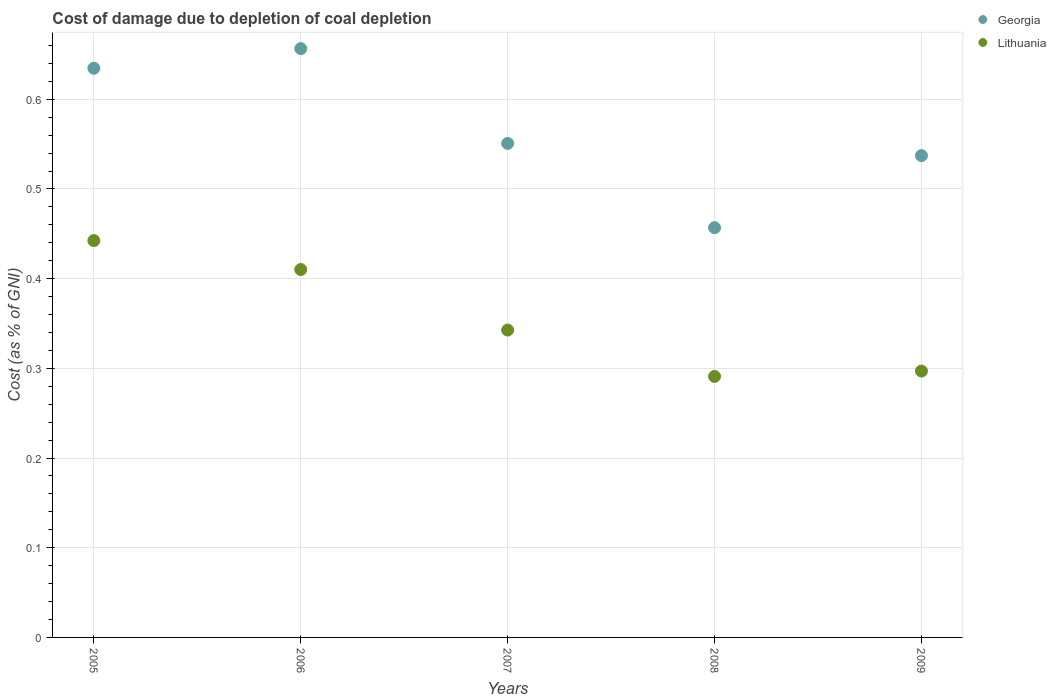What is the cost of damage caused due to coal depletion in Lithuania in 2008?
Offer a very short reply. 0.29. Across all years, what is the maximum cost of damage caused due to coal depletion in Lithuania?
Your answer should be compact. 0.44. Across all years, what is the minimum cost of damage caused due to coal depletion in Lithuania?
Your answer should be compact. 0.29. In which year was the cost of damage caused due to coal depletion in Lithuania minimum?
Provide a short and direct response. 2008. What is the total cost of damage caused due to coal depletion in Georgia in the graph?
Provide a succinct answer. 2.84. What is the difference between the cost of damage caused due to coal depletion in Lithuania in 2007 and that in 2008?
Ensure brevity in your answer.  0.05. What is the difference between the cost of damage caused due to coal depletion in Georgia in 2005 and the cost of damage caused due to coal depletion in Lithuania in 2008?
Keep it short and to the point. 0.34. What is the average cost of damage caused due to coal depletion in Georgia per year?
Keep it short and to the point. 0.57. In the year 2006, what is the difference between the cost of damage caused due to coal depletion in Lithuania and cost of damage caused due to coal depletion in Georgia?
Ensure brevity in your answer.  -0.25. In how many years, is the cost of damage caused due to coal depletion in Lithuania greater than 0.56 %?
Your response must be concise. 0. What is the ratio of the cost of damage caused due to coal depletion in Lithuania in 2008 to that in 2009?
Your answer should be compact. 0.98. Is the difference between the cost of damage caused due to coal depletion in Lithuania in 2006 and 2007 greater than the difference between the cost of damage caused due to coal depletion in Georgia in 2006 and 2007?
Provide a succinct answer. No. What is the difference between the highest and the second highest cost of damage caused due to coal depletion in Georgia?
Ensure brevity in your answer.  0.02. What is the difference between the highest and the lowest cost of damage caused due to coal depletion in Georgia?
Your answer should be compact. 0.2. In how many years, is the cost of damage caused due to coal depletion in Georgia greater than the average cost of damage caused due to coal depletion in Georgia taken over all years?
Provide a short and direct response. 2. Is the sum of the cost of damage caused due to coal depletion in Georgia in 2008 and 2009 greater than the maximum cost of damage caused due to coal depletion in Lithuania across all years?
Your response must be concise. Yes. Is the cost of damage caused due to coal depletion in Georgia strictly greater than the cost of damage caused due to coal depletion in Lithuania over the years?
Offer a very short reply. Yes. Is the cost of damage caused due to coal depletion in Lithuania strictly less than the cost of damage caused due to coal depletion in Georgia over the years?
Offer a terse response. Yes. How many dotlines are there?
Your response must be concise. 2. Are the values on the major ticks of Y-axis written in scientific E-notation?
Provide a short and direct response. No. How many legend labels are there?
Offer a very short reply. 2. What is the title of the graph?
Your response must be concise. Cost of damage due to depletion of coal depletion. What is the label or title of the X-axis?
Ensure brevity in your answer.  Years. What is the label or title of the Y-axis?
Offer a terse response. Cost (as % of GNI). What is the Cost (as % of GNI) of Georgia in 2005?
Keep it short and to the point. 0.63. What is the Cost (as % of GNI) in Lithuania in 2005?
Provide a short and direct response. 0.44. What is the Cost (as % of GNI) in Georgia in 2006?
Provide a short and direct response. 0.66. What is the Cost (as % of GNI) of Lithuania in 2006?
Your answer should be very brief. 0.41. What is the Cost (as % of GNI) in Georgia in 2007?
Your answer should be compact. 0.55. What is the Cost (as % of GNI) of Lithuania in 2007?
Provide a succinct answer. 0.34. What is the Cost (as % of GNI) of Georgia in 2008?
Give a very brief answer. 0.46. What is the Cost (as % of GNI) of Lithuania in 2008?
Your response must be concise. 0.29. What is the Cost (as % of GNI) of Georgia in 2009?
Make the answer very short. 0.54. What is the Cost (as % of GNI) in Lithuania in 2009?
Your answer should be compact. 0.3. Across all years, what is the maximum Cost (as % of GNI) in Georgia?
Ensure brevity in your answer.  0.66. Across all years, what is the maximum Cost (as % of GNI) of Lithuania?
Your answer should be compact. 0.44. Across all years, what is the minimum Cost (as % of GNI) in Georgia?
Your answer should be very brief. 0.46. Across all years, what is the minimum Cost (as % of GNI) in Lithuania?
Make the answer very short. 0.29. What is the total Cost (as % of GNI) in Georgia in the graph?
Provide a short and direct response. 2.84. What is the total Cost (as % of GNI) in Lithuania in the graph?
Offer a very short reply. 1.78. What is the difference between the Cost (as % of GNI) of Georgia in 2005 and that in 2006?
Make the answer very short. -0.02. What is the difference between the Cost (as % of GNI) in Lithuania in 2005 and that in 2006?
Provide a succinct answer. 0.03. What is the difference between the Cost (as % of GNI) in Georgia in 2005 and that in 2007?
Ensure brevity in your answer.  0.08. What is the difference between the Cost (as % of GNI) of Lithuania in 2005 and that in 2007?
Provide a short and direct response. 0.1. What is the difference between the Cost (as % of GNI) in Georgia in 2005 and that in 2008?
Offer a terse response. 0.18. What is the difference between the Cost (as % of GNI) of Lithuania in 2005 and that in 2008?
Provide a short and direct response. 0.15. What is the difference between the Cost (as % of GNI) in Georgia in 2005 and that in 2009?
Your response must be concise. 0.1. What is the difference between the Cost (as % of GNI) in Lithuania in 2005 and that in 2009?
Make the answer very short. 0.15. What is the difference between the Cost (as % of GNI) in Georgia in 2006 and that in 2007?
Ensure brevity in your answer.  0.11. What is the difference between the Cost (as % of GNI) of Lithuania in 2006 and that in 2007?
Give a very brief answer. 0.07. What is the difference between the Cost (as % of GNI) in Georgia in 2006 and that in 2008?
Provide a short and direct response. 0.2. What is the difference between the Cost (as % of GNI) in Lithuania in 2006 and that in 2008?
Provide a short and direct response. 0.12. What is the difference between the Cost (as % of GNI) in Georgia in 2006 and that in 2009?
Ensure brevity in your answer.  0.12. What is the difference between the Cost (as % of GNI) in Lithuania in 2006 and that in 2009?
Your answer should be very brief. 0.11. What is the difference between the Cost (as % of GNI) of Georgia in 2007 and that in 2008?
Keep it short and to the point. 0.09. What is the difference between the Cost (as % of GNI) of Lithuania in 2007 and that in 2008?
Offer a very short reply. 0.05. What is the difference between the Cost (as % of GNI) of Georgia in 2007 and that in 2009?
Offer a very short reply. 0.01. What is the difference between the Cost (as % of GNI) in Lithuania in 2007 and that in 2009?
Offer a terse response. 0.05. What is the difference between the Cost (as % of GNI) in Georgia in 2008 and that in 2009?
Keep it short and to the point. -0.08. What is the difference between the Cost (as % of GNI) in Lithuania in 2008 and that in 2009?
Make the answer very short. -0.01. What is the difference between the Cost (as % of GNI) of Georgia in 2005 and the Cost (as % of GNI) of Lithuania in 2006?
Provide a short and direct response. 0.22. What is the difference between the Cost (as % of GNI) of Georgia in 2005 and the Cost (as % of GNI) of Lithuania in 2007?
Keep it short and to the point. 0.29. What is the difference between the Cost (as % of GNI) of Georgia in 2005 and the Cost (as % of GNI) of Lithuania in 2008?
Keep it short and to the point. 0.34. What is the difference between the Cost (as % of GNI) of Georgia in 2005 and the Cost (as % of GNI) of Lithuania in 2009?
Ensure brevity in your answer.  0.34. What is the difference between the Cost (as % of GNI) in Georgia in 2006 and the Cost (as % of GNI) in Lithuania in 2007?
Offer a terse response. 0.31. What is the difference between the Cost (as % of GNI) in Georgia in 2006 and the Cost (as % of GNI) in Lithuania in 2008?
Your answer should be very brief. 0.37. What is the difference between the Cost (as % of GNI) of Georgia in 2006 and the Cost (as % of GNI) of Lithuania in 2009?
Provide a short and direct response. 0.36. What is the difference between the Cost (as % of GNI) of Georgia in 2007 and the Cost (as % of GNI) of Lithuania in 2008?
Your response must be concise. 0.26. What is the difference between the Cost (as % of GNI) of Georgia in 2007 and the Cost (as % of GNI) of Lithuania in 2009?
Offer a very short reply. 0.25. What is the difference between the Cost (as % of GNI) in Georgia in 2008 and the Cost (as % of GNI) in Lithuania in 2009?
Ensure brevity in your answer.  0.16. What is the average Cost (as % of GNI) in Georgia per year?
Offer a terse response. 0.57. What is the average Cost (as % of GNI) in Lithuania per year?
Keep it short and to the point. 0.36. In the year 2005, what is the difference between the Cost (as % of GNI) in Georgia and Cost (as % of GNI) in Lithuania?
Provide a succinct answer. 0.19. In the year 2006, what is the difference between the Cost (as % of GNI) of Georgia and Cost (as % of GNI) of Lithuania?
Provide a short and direct response. 0.25. In the year 2007, what is the difference between the Cost (as % of GNI) of Georgia and Cost (as % of GNI) of Lithuania?
Make the answer very short. 0.21. In the year 2008, what is the difference between the Cost (as % of GNI) of Georgia and Cost (as % of GNI) of Lithuania?
Provide a succinct answer. 0.17. In the year 2009, what is the difference between the Cost (as % of GNI) of Georgia and Cost (as % of GNI) of Lithuania?
Provide a short and direct response. 0.24. What is the ratio of the Cost (as % of GNI) in Georgia in 2005 to that in 2006?
Ensure brevity in your answer.  0.97. What is the ratio of the Cost (as % of GNI) of Lithuania in 2005 to that in 2006?
Provide a short and direct response. 1.08. What is the ratio of the Cost (as % of GNI) in Georgia in 2005 to that in 2007?
Offer a terse response. 1.15. What is the ratio of the Cost (as % of GNI) in Lithuania in 2005 to that in 2007?
Ensure brevity in your answer.  1.29. What is the ratio of the Cost (as % of GNI) in Georgia in 2005 to that in 2008?
Offer a terse response. 1.39. What is the ratio of the Cost (as % of GNI) in Lithuania in 2005 to that in 2008?
Keep it short and to the point. 1.52. What is the ratio of the Cost (as % of GNI) of Georgia in 2005 to that in 2009?
Provide a succinct answer. 1.18. What is the ratio of the Cost (as % of GNI) in Lithuania in 2005 to that in 2009?
Your answer should be compact. 1.49. What is the ratio of the Cost (as % of GNI) of Georgia in 2006 to that in 2007?
Make the answer very short. 1.19. What is the ratio of the Cost (as % of GNI) of Lithuania in 2006 to that in 2007?
Keep it short and to the point. 1.2. What is the ratio of the Cost (as % of GNI) of Georgia in 2006 to that in 2008?
Offer a very short reply. 1.44. What is the ratio of the Cost (as % of GNI) of Lithuania in 2006 to that in 2008?
Keep it short and to the point. 1.41. What is the ratio of the Cost (as % of GNI) of Georgia in 2006 to that in 2009?
Your answer should be compact. 1.22. What is the ratio of the Cost (as % of GNI) of Lithuania in 2006 to that in 2009?
Provide a succinct answer. 1.38. What is the ratio of the Cost (as % of GNI) in Georgia in 2007 to that in 2008?
Make the answer very short. 1.21. What is the ratio of the Cost (as % of GNI) of Lithuania in 2007 to that in 2008?
Your answer should be very brief. 1.18. What is the ratio of the Cost (as % of GNI) in Georgia in 2007 to that in 2009?
Offer a terse response. 1.03. What is the ratio of the Cost (as % of GNI) of Lithuania in 2007 to that in 2009?
Give a very brief answer. 1.15. What is the ratio of the Cost (as % of GNI) in Georgia in 2008 to that in 2009?
Ensure brevity in your answer.  0.85. What is the ratio of the Cost (as % of GNI) of Lithuania in 2008 to that in 2009?
Make the answer very short. 0.98. What is the difference between the highest and the second highest Cost (as % of GNI) in Georgia?
Your response must be concise. 0.02. What is the difference between the highest and the second highest Cost (as % of GNI) in Lithuania?
Make the answer very short. 0.03. What is the difference between the highest and the lowest Cost (as % of GNI) in Georgia?
Provide a short and direct response. 0.2. What is the difference between the highest and the lowest Cost (as % of GNI) in Lithuania?
Provide a short and direct response. 0.15. 